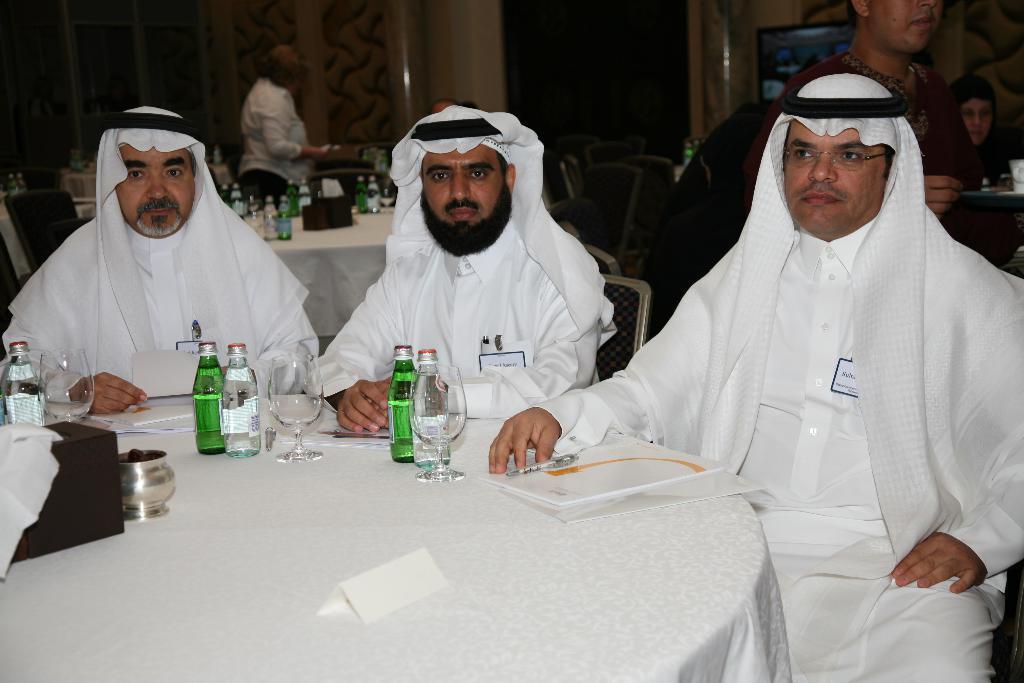In one or two sentences, can you explain what this image depicts? In this picture we can see three people sitting on chair and in front of them there is table and on table we have bottle, glass, jar, tissue paper box, papers and in background we can see person standing, wall. 